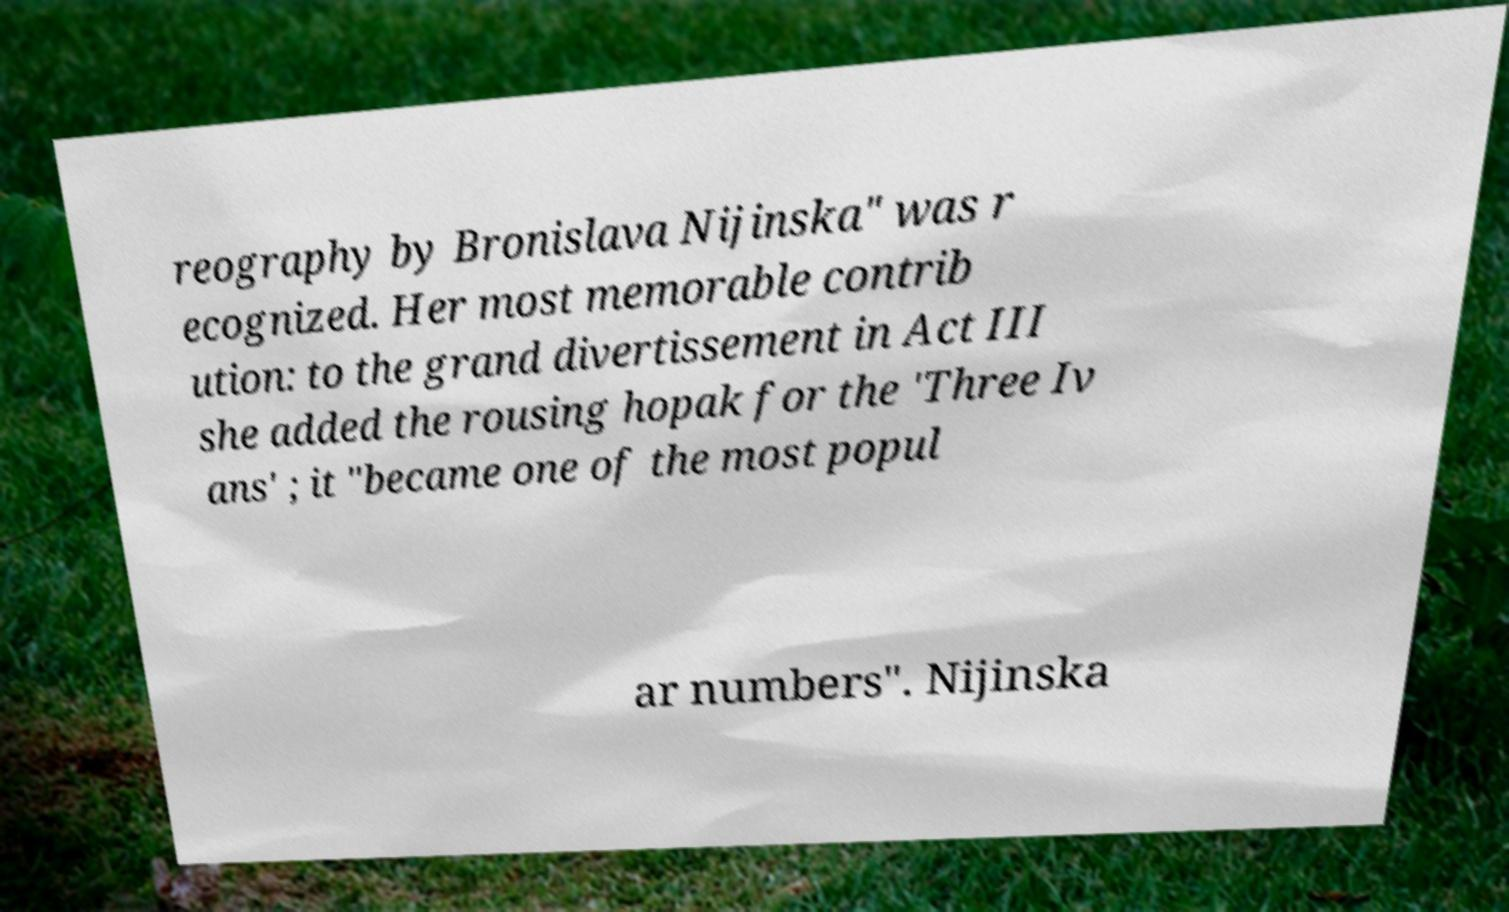Could you extract and type out the text from this image? reography by Bronislava Nijinska" was r ecognized. Her most memorable contrib ution: to the grand divertissement in Act III she added the rousing hopak for the 'Three Iv ans' ; it "became one of the most popul ar numbers". Nijinska 